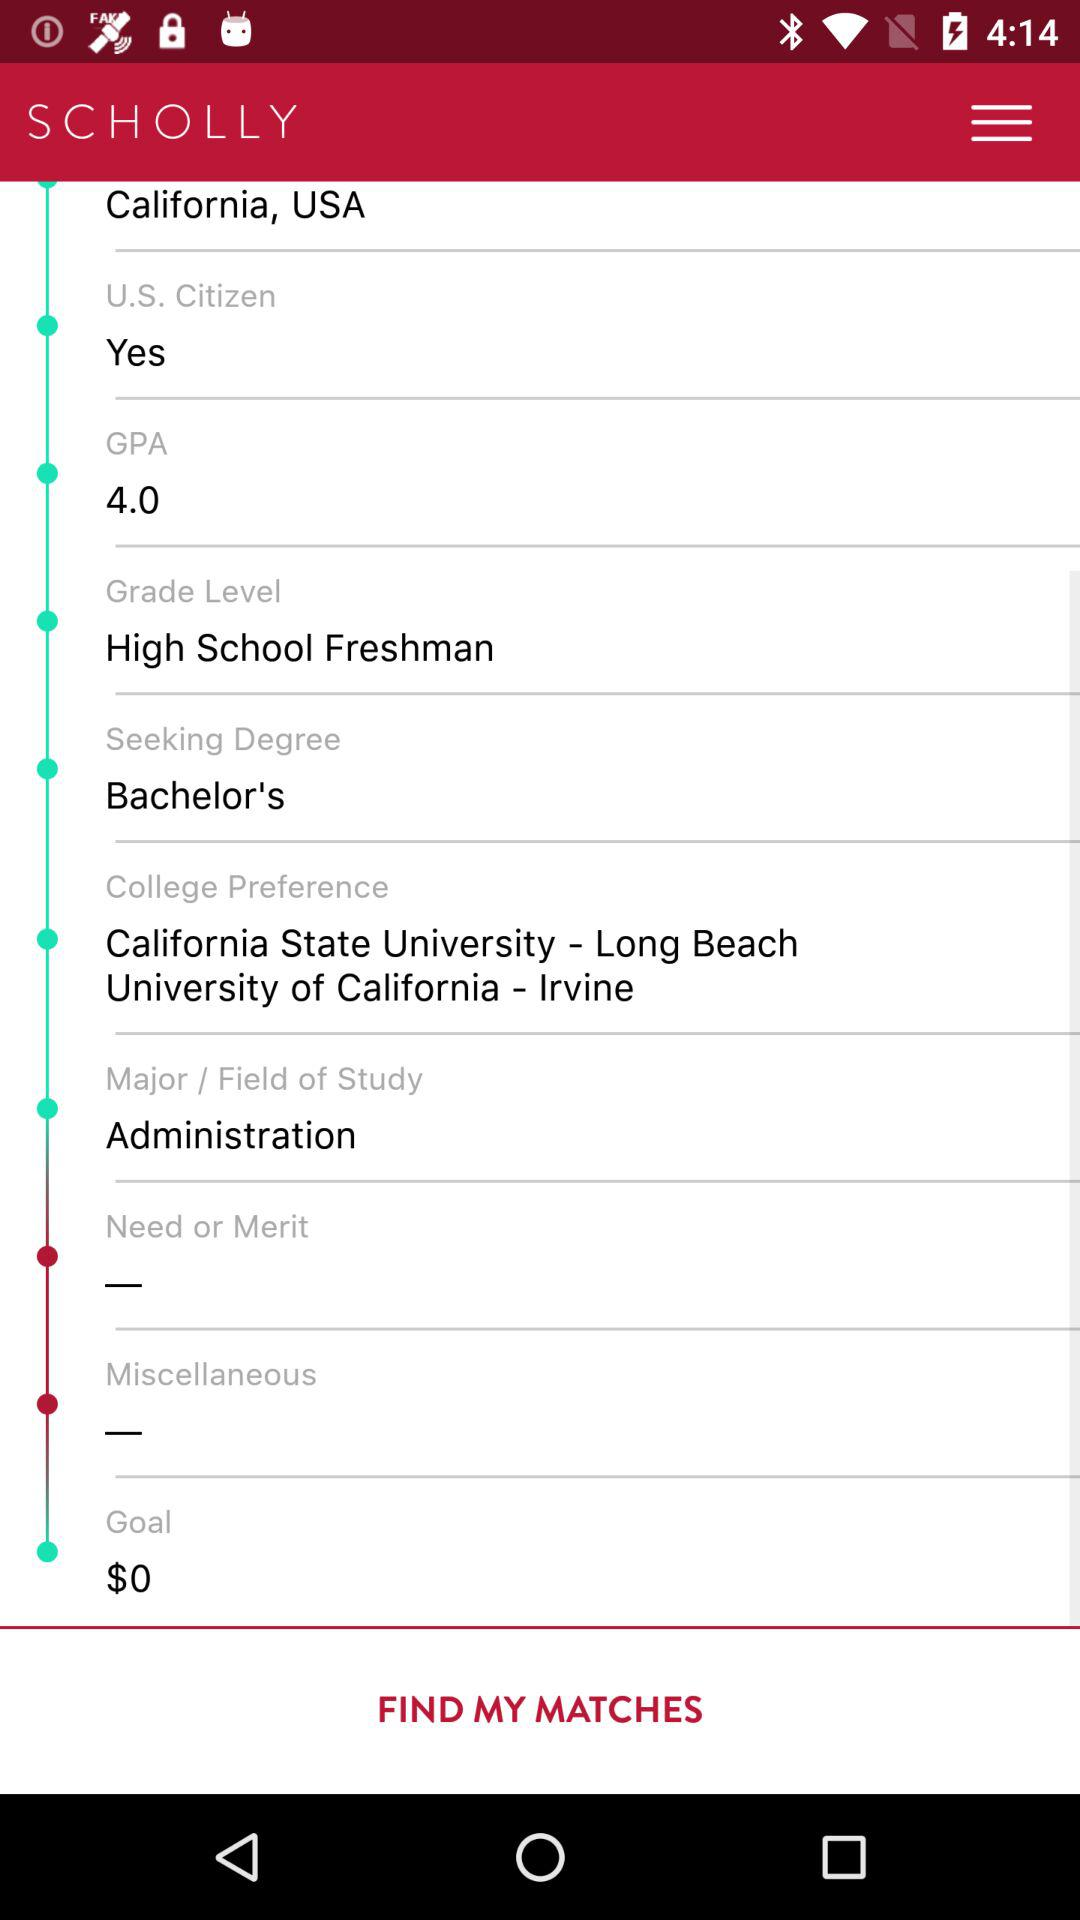What is the grade level? The grade level is "High School Freshman". 